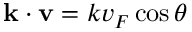<formula> <loc_0><loc_0><loc_500><loc_500>{ k } \cdot { v } = k v _ { F } \cos \theta</formula> 